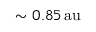Convert formula to latex. <formula><loc_0><loc_0><loc_500><loc_500>\sim 0 . 8 5 \, a u</formula> 